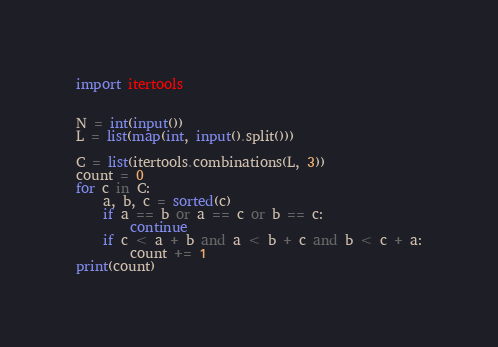Convert code to text. <code><loc_0><loc_0><loc_500><loc_500><_Python_>import itertools


N = int(input())
L = list(map(int, input().split()))

C = list(itertools.combinations(L, 3))
count = 0
for c in C:
    a, b, c = sorted(c)
    if a == b or a == c or b == c:
        continue
    if c < a + b and a < b + c and b < c + a:
        count += 1
print(count)</code> 